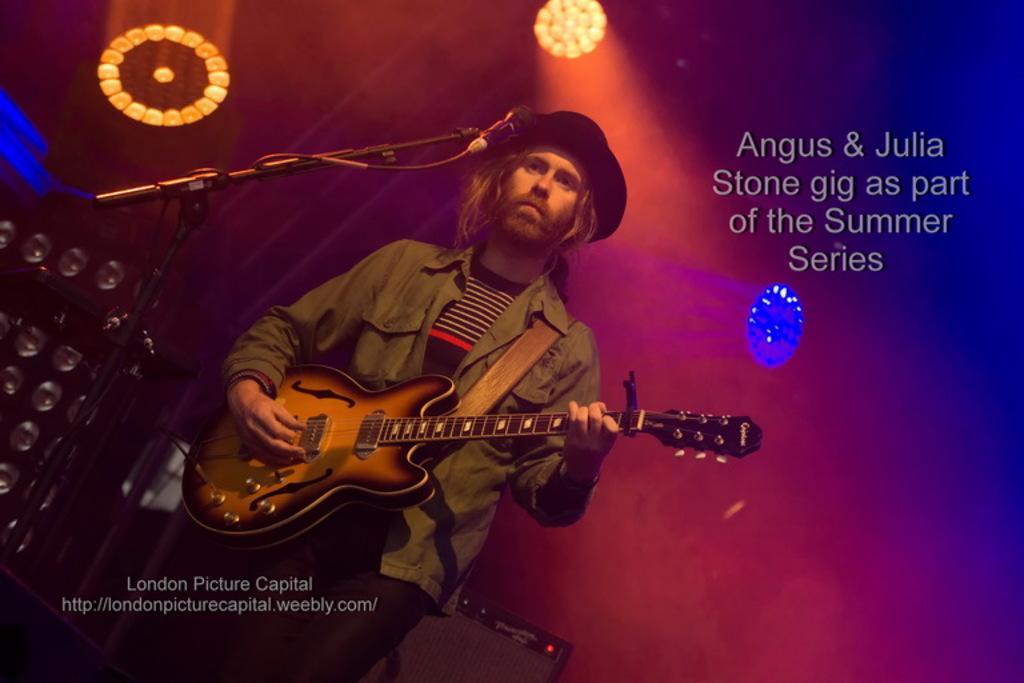Describe this image in one or two sentences. In this image there is a man standing and playing a guitar, at the background there is microphone, speakers, focus lights. 